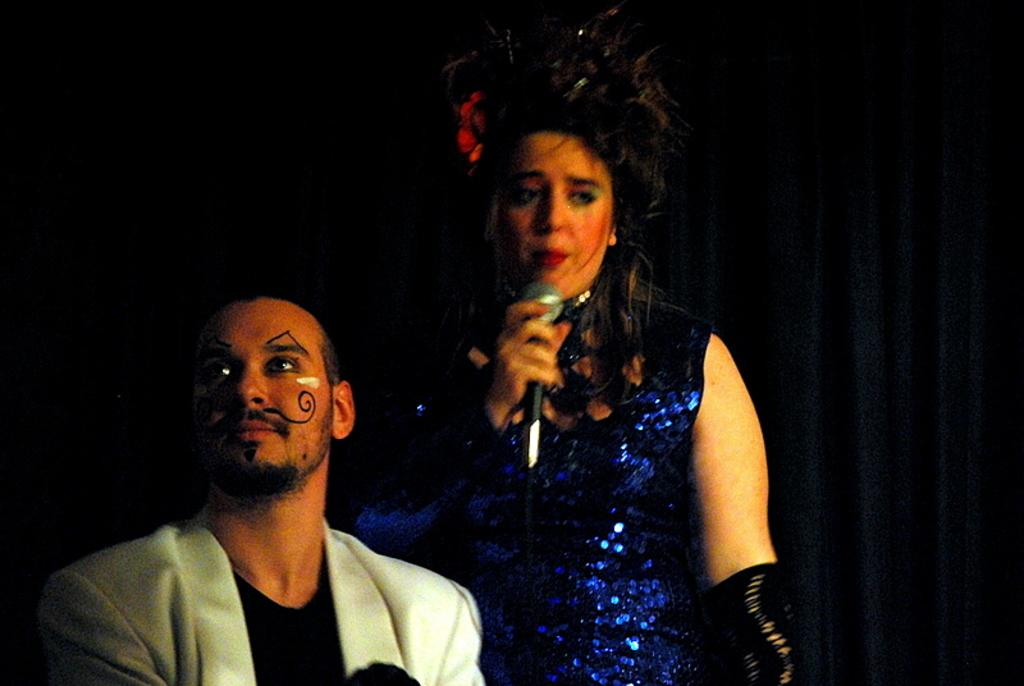How many people are in the image? There are two persons in the image. What is the person on the right side holding? The person on the right side is holding a microphone. What type of fabric can be seen in the image? There are curtains visible in the image. Can you tell me how many beetles are crawling on the curtains in the image? There are no beetles visible in the image, so it is not possible to determine how many beetles might be crawling on the curtains. 